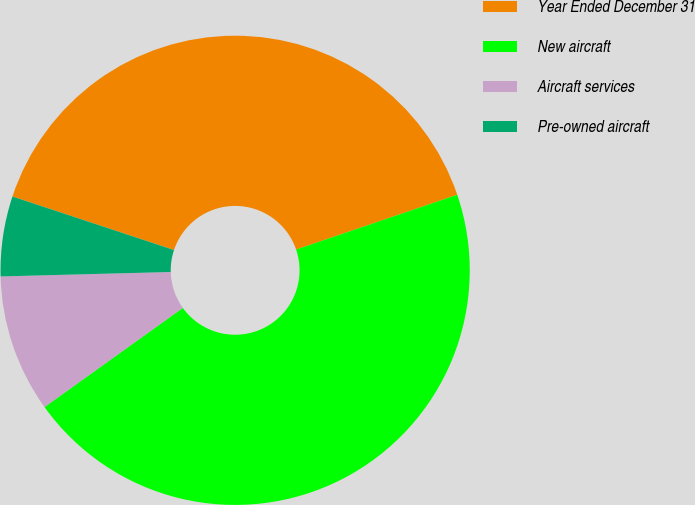Convert chart. <chart><loc_0><loc_0><loc_500><loc_500><pie_chart><fcel>Year Ended December 31<fcel>New aircraft<fcel>Aircraft services<fcel>Pre-owned aircraft<nl><fcel>39.69%<fcel>45.32%<fcel>9.49%<fcel>5.51%<nl></chart> 